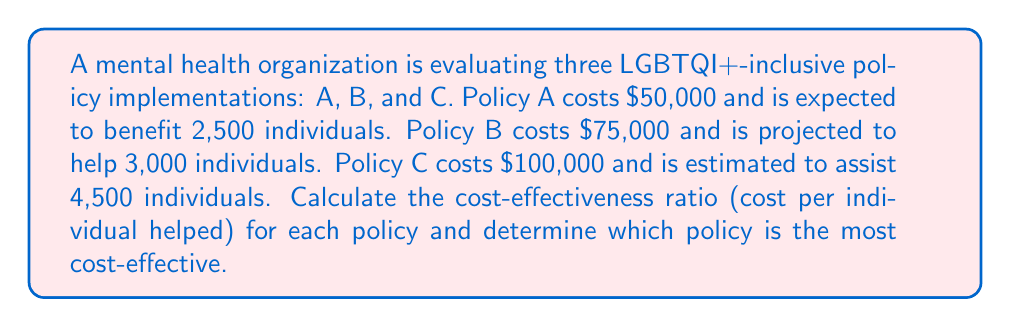Can you solve this math problem? To calculate the cost-effectiveness ratio for each policy, we'll use the formula:

$$ \text{Cost-effectiveness ratio} = \frac{\text{Total cost}}{\text{Number of individuals helped}} $$

For Policy A:
$$ \text{Ratio}_A = \frac{\$50,000}{2,500} = \$20 \text{ per individual} $$

For Policy B:
$$ \text{Ratio}_B = \frac{\$75,000}{3,000} = \$25 \text{ per individual} $$

For Policy C:
$$ \text{Ratio}_C = \frac{\$100,000}{4,500} = \$22.22 \text{ per individual} $$

The most cost-effective policy is the one with the lowest cost per individual helped. Comparing the ratios:

$$ \text{Ratio}_A < \text{Ratio}_C < \text{Ratio}_B $$

Therefore, Policy A is the most cost-effective, costing $20 per individual helped.
Answer: Policy A; $20 per individual 